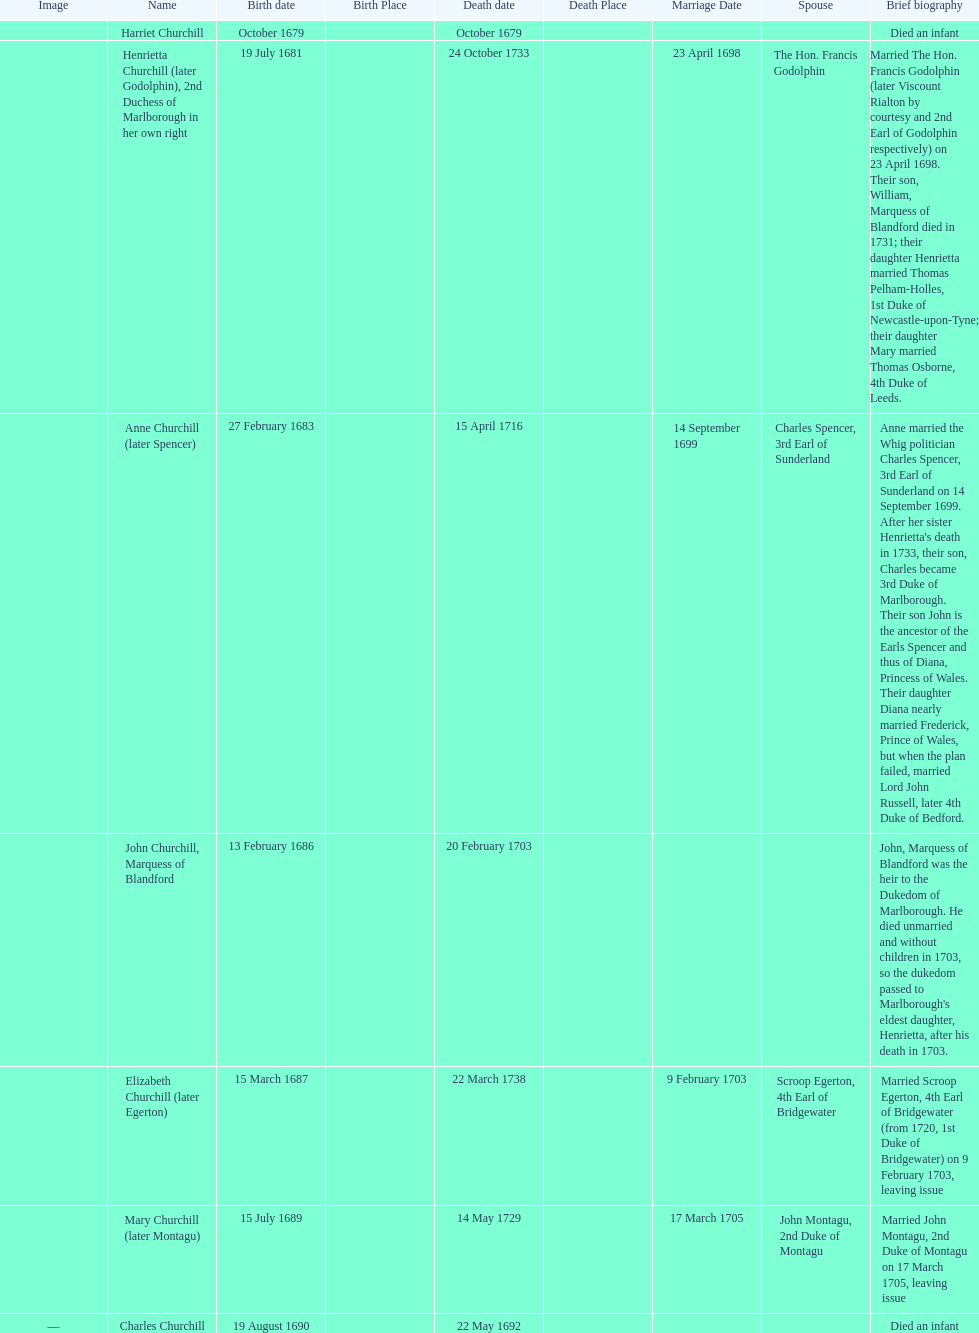Who was born first? mary churchill or elizabeth churchill? Elizabeth Churchill. 